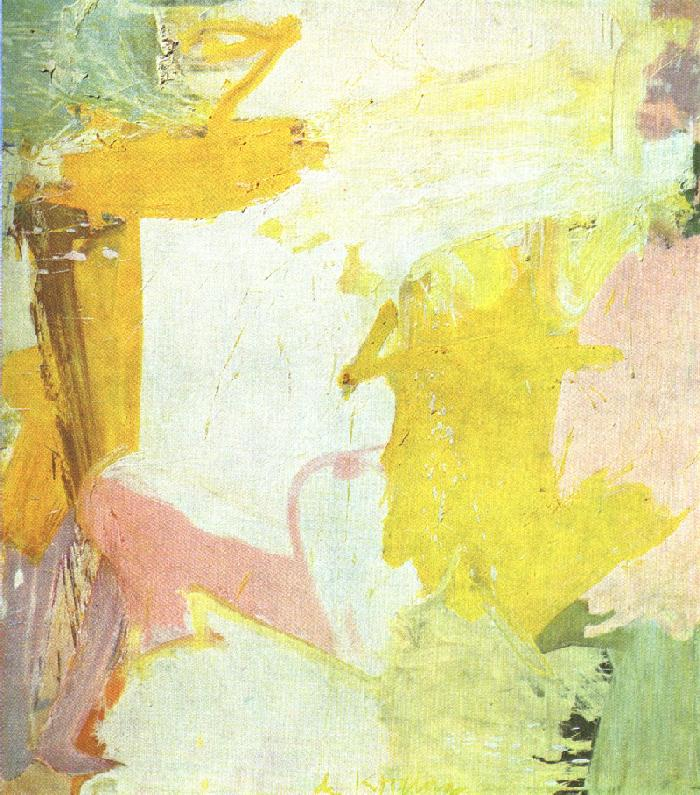Write a detailed description of the given image. The image you've shared is a captivating piece of abstract art characterized by its dynamic composition and vibrant pastel colors. The palette prominently showcases hues of yellow, pink, and white, creating a harmonious blend that is both soothing and visually stimulating. The artist employs a variety of brushstrokes and textures, adding depth and richness to the piece. The work exudes an ethereal and airy atmosphere, reminiscent of the post-impressionism movement, where the emphasis is placed on color and form over realistic representation. The overall impression is one of fluidity and motion, inviting viewers to immerse themselves in the emotions and interpretations elicited by the artwork. This abstract piece beautifully demonstrates how art can transcend literal meaning, offering an open canvas for individual emotional and intellectual exploration. 